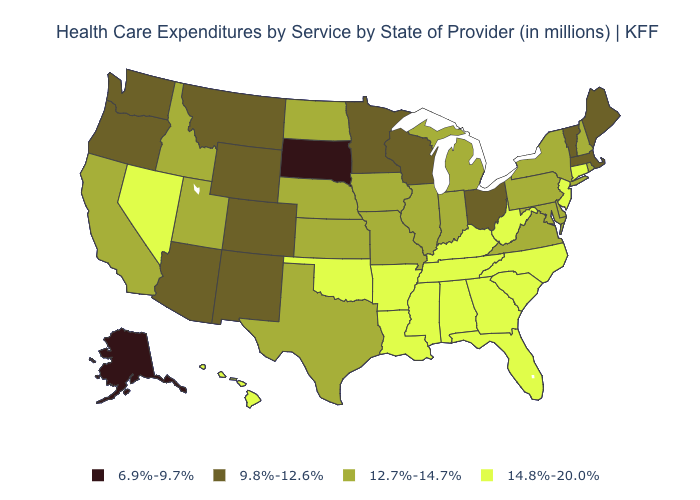Name the states that have a value in the range 14.8%-20.0%?
Give a very brief answer. Alabama, Arkansas, Connecticut, Florida, Georgia, Hawaii, Kentucky, Louisiana, Mississippi, Nevada, New Jersey, North Carolina, Oklahoma, South Carolina, Tennessee, West Virginia. What is the value of Virginia?
Concise answer only. 12.7%-14.7%. Does Michigan have a lower value than Tennessee?
Concise answer only. Yes. What is the value of Florida?
Write a very short answer. 14.8%-20.0%. What is the value of Nebraska?
Quick response, please. 12.7%-14.7%. Does South Dakota have the lowest value in the USA?
Give a very brief answer. Yes. Name the states that have a value in the range 9.8%-12.6%?
Write a very short answer. Arizona, Colorado, Maine, Massachusetts, Minnesota, Montana, New Mexico, Ohio, Oregon, Vermont, Washington, Wisconsin, Wyoming. Which states have the highest value in the USA?
Write a very short answer. Alabama, Arkansas, Connecticut, Florida, Georgia, Hawaii, Kentucky, Louisiana, Mississippi, Nevada, New Jersey, North Carolina, Oklahoma, South Carolina, Tennessee, West Virginia. What is the lowest value in states that border Wisconsin?
Keep it brief. 9.8%-12.6%. What is the value of Hawaii?
Give a very brief answer. 14.8%-20.0%. What is the lowest value in the Northeast?
Write a very short answer. 9.8%-12.6%. Among the states that border Rhode Island , which have the highest value?
Answer briefly. Connecticut. Name the states that have a value in the range 6.9%-9.7%?
Quick response, please. Alaska, South Dakota. Does Minnesota have the same value as Ohio?
Answer briefly. Yes. Name the states that have a value in the range 6.9%-9.7%?
Quick response, please. Alaska, South Dakota. 